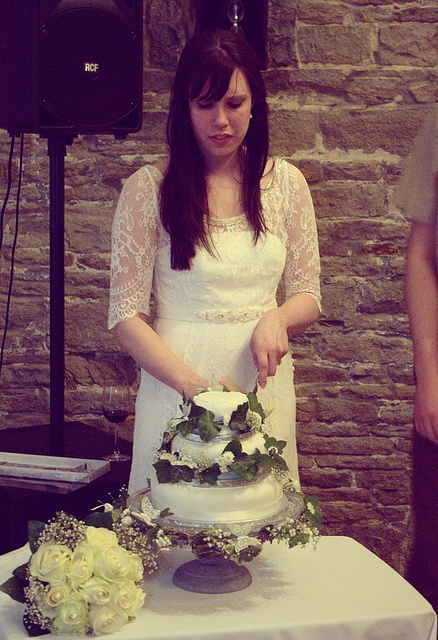Describe the objects in this image and their specific colors. I can see people in purple, khaki, navy, darkgray, and tan tones, dining table in purple, tan, and darkgray tones, people in purple and brown tones, cake in purple, darkgray, khaki, tan, and gray tones, and cake in purple, khaki, gray, darkgray, and black tones in this image. 